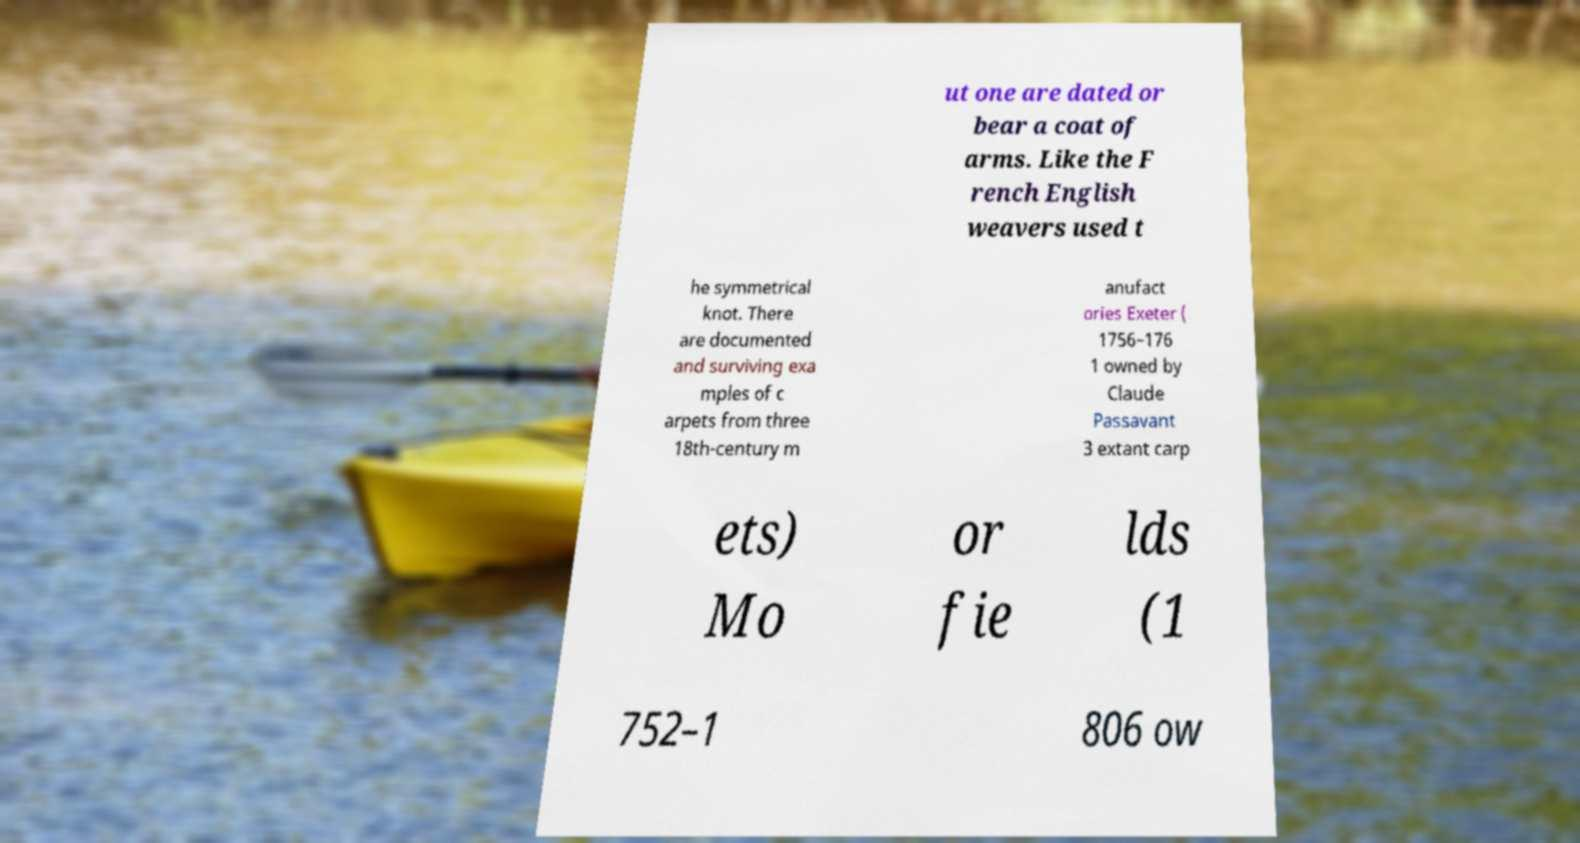I need the written content from this picture converted into text. Can you do that? ut one are dated or bear a coat of arms. Like the F rench English weavers used t he symmetrical knot. There are documented and surviving exa mples of c arpets from three 18th-century m anufact ories Exeter ( 1756–176 1 owned by Claude Passavant 3 extant carp ets) Mo or fie lds (1 752–1 806 ow 